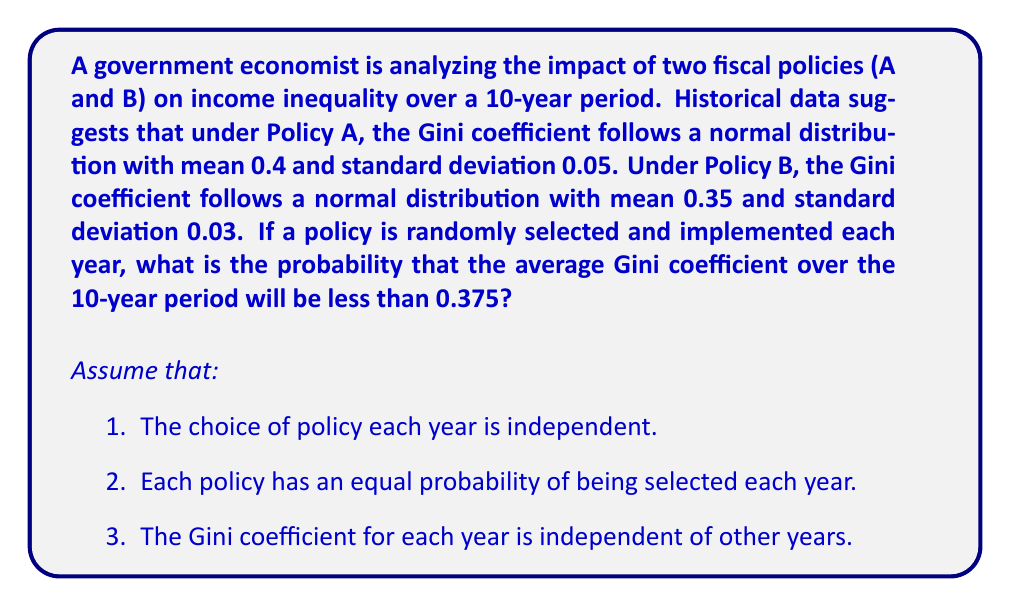Provide a solution to this math problem. Let's approach this step-by-step:

1) First, we need to determine the distribution of the Gini coefficient for a single year:

   Let $X$ be the Gini coefficient for a single year.
   $X = \begin{cases} 
   N(0.4, 0.05^2) & \text{with probability } 0.5 \text{ (Policy A)}\\
   N(0.35, 0.03^2) & \text{with probability } 0.5 \text{ (Policy B)}
   \end{cases}$

2) The mean of $X$ is:
   $E[X] = 0.5 \cdot 0.4 + 0.5 \cdot 0.35 = 0.375$

3) The variance of $X$ is:
   $Var(X) = E[X^2] - (E[X])^2$
   $E[X^2] = 0.5(0.4^2 + 0.05^2) + 0.5(0.35^2 + 0.03^2) = 0.141325$
   $Var(X) = 0.141325 - 0.375^2 = 0.000825$

4) Now, let $\bar{X}$ be the average Gini coefficient over 10 years.
   By the Central Limit Theorem, $\bar{X}$ follows a normal distribution:
   $\bar{X} \sim N(0.375, \frac{0.000825}{10})$

5) We want to find $P(\bar{X} < 0.375)$

6) Standardizing:
   $Z = \frac{\bar{X} - 0.375}{\sqrt{0.000825/10}} = \frac{\bar{X} - 0.375}{0.00908}$

7) Therefore, $P(\bar{X} < 0.375) = P(Z < 0) = 0.5$
Answer: 0.5 